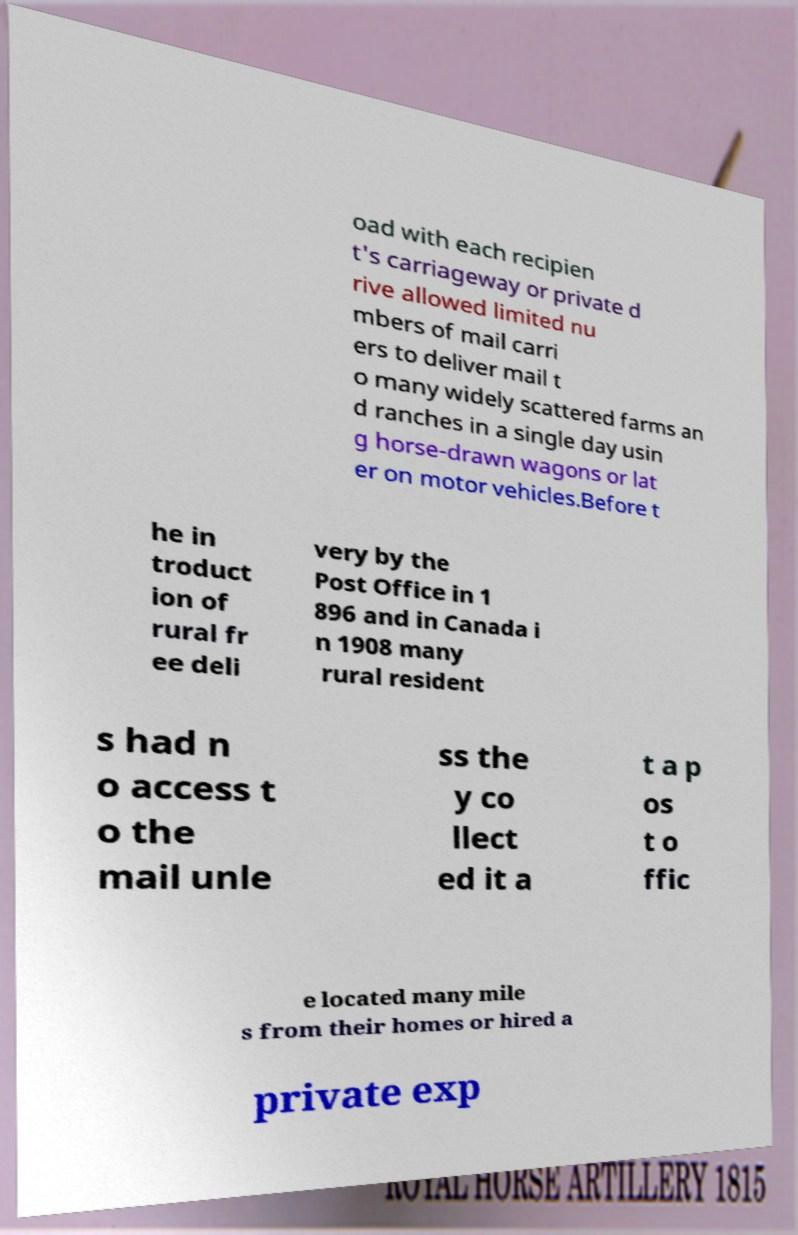What messages or text are displayed in this image? I need them in a readable, typed format. oad with each recipien t's carriageway or private d rive allowed limited nu mbers of mail carri ers to deliver mail t o many widely scattered farms an d ranches in a single day usin g horse-drawn wagons or lat er on motor vehicles.Before t he in troduct ion of rural fr ee deli very by the Post Office in 1 896 and in Canada i n 1908 many rural resident s had n o access t o the mail unle ss the y co llect ed it a t a p os t o ffic e located many mile s from their homes or hired a private exp 